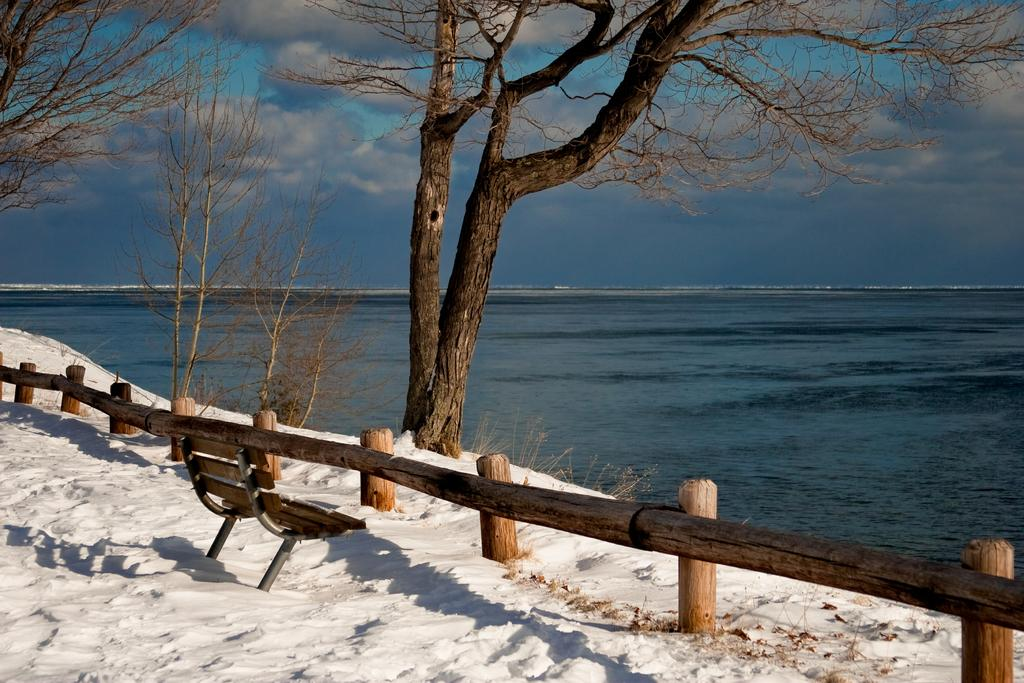What type of seating is visible in the image? There is a bench in the image. Where is the bench located in relation to other objects? The bench is in front of a fence. What is the condition of the ground around the bench? The bench is on a snowy land. What can be seen in the distance behind the bench? There is a sea visible in the background of the image. What is visible above the bench and the sea? The sky is visible in the image, and clouds are present in the sky. How many spots can be seen on the lock in the image? There is no lock present in the image, so the number of spots cannot be determined. 